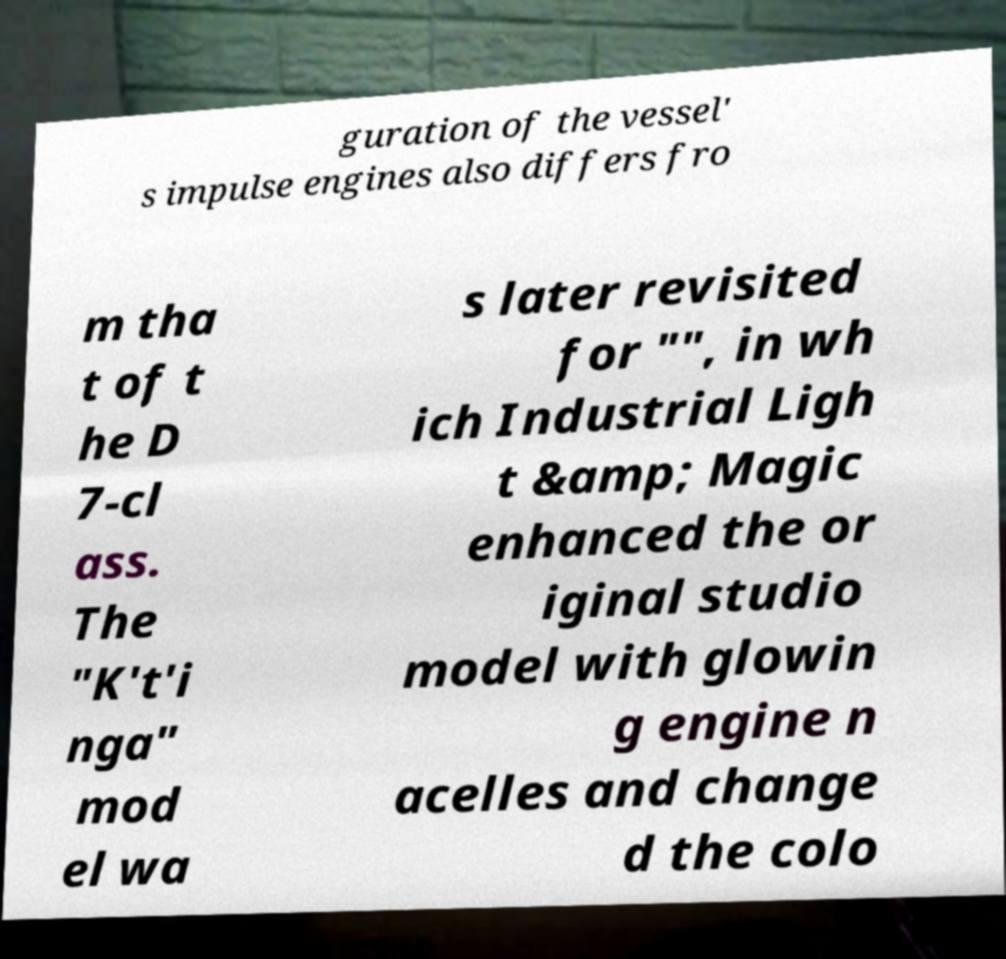There's text embedded in this image that I need extracted. Can you transcribe it verbatim? guration of the vessel' s impulse engines also differs fro m tha t of t he D 7-cl ass. The "K't'i nga" mod el wa s later revisited for "", in wh ich Industrial Ligh t &amp; Magic enhanced the or iginal studio model with glowin g engine n acelles and change d the colo 